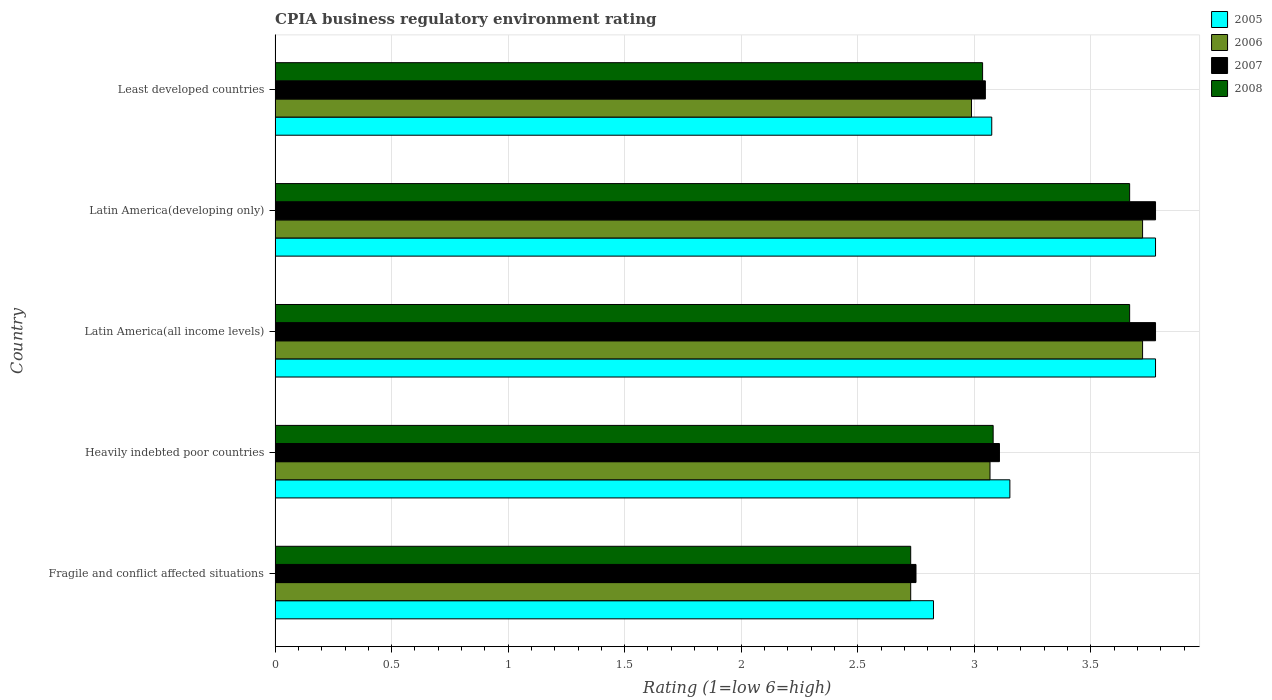How many different coloured bars are there?
Make the answer very short. 4. How many groups of bars are there?
Provide a succinct answer. 5. Are the number of bars per tick equal to the number of legend labels?
Give a very brief answer. Yes. Are the number of bars on each tick of the Y-axis equal?
Your answer should be compact. Yes. What is the label of the 4th group of bars from the top?
Offer a terse response. Heavily indebted poor countries. What is the CPIA rating in 2008 in Latin America(all income levels)?
Your answer should be compact. 3.67. Across all countries, what is the maximum CPIA rating in 2007?
Make the answer very short. 3.78. Across all countries, what is the minimum CPIA rating in 2005?
Your answer should be very brief. 2.83. In which country was the CPIA rating in 2008 maximum?
Your answer should be compact. Latin America(all income levels). In which country was the CPIA rating in 2007 minimum?
Your answer should be very brief. Fragile and conflict affected situations. What is the total CPIA rating in 2008 in the graph?
Make the answer very short. 16.18. What is the difference between the CPIA rating in 2006 in Fragile and conflict affected situations and that in Heavily indebted poor countries?
Keep it short and to the point. -0.34. What is the difference between the CPIA rating in 2008 in Heavily indebted poor countries and the CPIA rating in 2007 in Fragile and conflict affected situations?
Ensure brevity in your answer.  0.33. What is the average CPIA rating in 2008 per country?
Ensure brevity in your answer.  3.24. What is the difference between the CPIA rating in 2008 and CPIA rating in 2006 in Latin America(all income levels)?
Make the answer very short. -0.06. In how many countries, is the CPIA rating in 2006 greater than 0.7 ?
Provide a succinct answer. 5. What is the ratio of the CPIA rating in 2008 in Heavily indebted poor countries to that in Latin America(all income levels)?
Ensure brevity in your answer.  0.84. Is the CPIA rating in 2006 in Fragile and conflict affected situations less than that in Heavily indebted poor countries?
Give a very brief answer. Yes. Is the difference between the CPIA rating in 2008 in Fragile and conflict affected situations and Latin America(all income levels) greater than the difference between the CPIA rating in 2006 in Fragile and conflict affected situations and Latin America(all income levels)?
Provide a succinct answer. Yes. What is the difference between the highest and the second highest CPIA rating in 2006?
Your answer should be compact. 0. What is the difference between the highest and the lowest CPIA rating in 2006?
Your response must be concise. 0.99. Is it the case that in every country, the sum of the CPIA rating in 2007 and CPIA rating in 2005 is greater than the sum of CPIA rating in 2006 and CPIA rating in 2008?
Keep it short and to the point. No. What does the 2nd bar from the bottom in Fragile and conflict affected situations represents?
Provide a succinct answer. 2006. Is it the case that in every country, the sum of the CPIA rating in 2006 and CPIA rating in 2007 is greater than the CPIA rating in 2008?
Offer a terse response. Yes. How many countries are there in the graph?
Your answer should be very brief. 5. What is the difference between two consecutive major ticks on the X-axis?
Your answer should be compact. 0.5. Are the values on the major ticks of X-axis written in scientific E-notation?
Offer a terse response. No. Does the graph contain any zero values?
Offer a terse response. No. Does the graph contain grids?
Offer a very short reply. Yes. Where does the legend appear in the graph?
Give a very brief answer. Top right. How many legend labels are there?
Your answer should be very brief. 4. What is the title of the graph?
Your response must be concise. CPIA business regulatory environment rating. What is the label or title of the X-axis?
Give a very brief answer. Rating (1=low 6=high). What is the label or title of the Y-axis?
Provide a short and direct response. Country. What is the Rating (1=low 6=high) of 2005 in Fragile and conflict affected situations?
Give a very brief answer. 2.83. What is the Rating (1=low 6=high) in 2006 in Fragile and conflict affected situations?
Offer a very short reply. 2.73. What is the Rating (1=low 6=high) of 2007 in Fragile and conflict affected situations?
Provide a short and direct response. 2.75. What is the Rating (1=low 6=high) of 2008 in Fragile and conflict affected situations?
Keep it short and to the point. 2.73. What is the Rating (1=low 6=high) in 2005 in Heavily indebted poor countries?
Your answer should be very brief. 3.15. What is the Rating (1=low 6=high) in 2006 in Heavily indebted poor countries?
Your answer should be very brief. 3.07. What is the Rating (1=low 6=high) of 2007 in Heavily indebted poor countries?
Provide a succinct answer. 3.11. What is the Rating (1=low 6=high) in 2008 in Heavily indebted poor countries?
Ensure brevity in your answer.  3.08. What is the Rating (1=low 6=high) of 2005 in Latin America(all income levels)?
Provide a succinct answer. 3.78. What is the Rating (1=low 6=high) in 2006 in Latin America(all income levels)?
Ensure brevity in your answer.  3.72. What is the Rating (1=low 6=high) of 2007 in Latin America(all income levels)?
Ensure brevity in your answer.  3.78. What is the Rating (1=low 6=high) of 2008 in Latin America(all income levels)?
Your response must be concise. 3.67. What is the Rating (1=low 6=high) of 2005 in Latin America(developing only)?
Make the answer very short. 3.78. What is the Rating (1=low 6=high) in 2006 in Latin America(developing only)?
Provide a succinct answer. 3.72. What is the Rating (1=low 6=high) of 2007 in Latin America(developing only)?
Offer a very short reply. 3.78. What is the Rating (1=low 6=high) in 2008 in Latin America(developing only)?
Keep it short and to the point. 3.67. What is the Rating (1=low 6=high) in 2005 in Least developed countries?
Your response must be concise. 3.08. What is the Rating (1=low 6=high) in 2006 in Least developed countries?
Your response must be concise. 2.99. What is the Rating (1=low 6=high) in 2007 in Least developed countries?
Offer a very short reply. 3.05. What is the Rating (1=low 6=high) of 2008 in Least developed countries?
Ensure brevity in your answer.  3.04. Across all countries, what is the maximum Rating (1=low 6=high) of 2005?
Your answer should be compact. 3.78. Across all countries, what is the maximum Rating (1=low 6=high) of 2006?
Ensure brevity in your answer.  3.72. Across all countries, what is the maximum Rating (1=low 6=high) of 2007?
Give a very brief answer. 3.78. Across all countries, what is the maximum Rating (1=low 6=high) of 2008?
Give a very brief answer. 3.67. Across all countries, what is the minimum Rating (1=low 6=high) of 2005?
Your response must be concise. 2.83. Across all countries, what is the minimum Rating (1=low 6=high) in 2006?
Your response must be concise. 2.73. Across all countries, what is the minimum Rating (1=low 6=high) in 2007?
Offer a very short reply. 2.75. Across all countries, what is the minimum Rating (1=low 6=high) in 2008?
Keep it short and to the point. 2.73. What is the total Rating (1=low 6=high) of 2005 in the graph?
Give a very brief answer. 16.61. What is the total Rating (1=low 6=high) of 2006 in the graph?
Provide a short and direct response. 16.23. What is the total Rating (1=low 6=high) in 2007 in the graph?
Keep it short and to the point. 16.46. What is the total Rating (1=low 6=high) of 2008 in the graph?
Keep it short and to the point. 16.18. What is the difference between the Rating (1=low 6=high) in 2005 in Fragile and conflict affected situations and that in Heavily indebted poor countries?
Make the answer very short. -0.33. What is the difference between the Rating (1=low 6=high) of 2006 in Fragile and conflict affected situations and that in Heavily indebted poor countries?
Offer a terse response. -0.34. What is the difference between the Rating (1=low 6=high) in 2007 in Fragile and conflict affected situations and that in Heavily indebted poor countries?
Ensure brevity in your answer.  -0.36. What is the difference between the Rating (1=low 6=high) in 2008 in Fragile and conflict affected situations and that in Heavily indebted poor countries?
Offer a terse response. -0.35. What is the difference between the Rating (1=low 6=high) of 2005 in Fragile and conflict affected situations and that in Latin America(all income levels)?
Provide a succinct answer. -0.95. What is the difference between the Rating (1=low 6=high) of 2006 in Fragile and conflict affected situations and that in Latin America(all income levels)?
Offer a terse response. -0.99. What is the difference between the Rating (1=low 6=high) of 2007 in Fragile and conflict affected situations and that in Latin America(all income levels)?
Make the answer very short. -1.03. What is the difference between the Rating (1=low 6=high) in 2008 in Fragile and conflict affected situations and that in Latin America(all income levels)?
Make the answer very short. -0.94. What is the difference between the Rating (1=low 6=high) in 2005 in Fragile and conflict affected situations and that in Latin America(developing only)?
Your answer should be very brief. -0.95. What is the difference between the Rating (1=low 6=high) in 2006 in Fragile and conflict affected situations and that in Latin America(developing only)?
Provide a short and direct response. -0.99. What is the difference between the Rating (1=low 6=high) in 2007 in Fragile and conflict affected situations and that in Latin America(developing only)?
Keep it short and to the point. -1.03. What is the difference between the Rating (1=low 6=high) in 2008 in Fragile and conflict affected situations and that in Latin America(developing only)?
Offer a very short reply. -0.94. What is the difference between the Rating (1=low 6=high) in 2006 in Fragile and conflict affected situations and that in Least developed countries?
Offer a very short reply. -0.26. What is the difference between the Rating (1=low 6=high) in 2007 in Fragile and conflict affected situations and that in Least developed countries?
Your response must be concise. -0.3. What is the difference between the Rating (1=low 6=high) of 2008 in Fragile and conflict affected situations and that in Least developed countries?
Ensure brevity in your answer.  -0.31. What is the difference between the Rating (1=low 6=high) in 2005 in Heavily indebted poor countries and that in Latin America(all income levels)?
Provide a short and direct response. -0.62. What is the difference between the Rating (1=low 6=high) of 2006 in Heavily indebted poor countries and that in Latin America(all income levels)?
Your answer should be compact. -0.65. What is the difference between the Rating (1=low 6=high) of 2007 in Heavily indebted poor countries and that in Latin America(all income levels)?
Your response must be concise. -0.67. What is the difference between the Rating (1=low 6=high) of 2008 in Heavily indebted poor countries and that in Latin America(all income levels)?
Make the answer very short. -0.59. What is the difference between the Rating (1=low 6=high) in 2005 in Heavily indebted poor countries and that in Latin America(developing only)?
Your answer should be compact. -0.62. What is the difference between the Rating (1=low 6=high) in 2006 in Heavily indebted poor countries and that in Latin America(developing only)?
Keep it short and to the point. -0.65. What is the difference between the Rating (1=low 6=high) in 2007 in Heavily indebted poor countries and that in Latin America(developing only)?
Keep it short and to the point. -0.67. What is the difference between the Rating (1=low 6=high) of 2008 in Heavily indebted poor countries and that in Latin America(developing only)?
Your answer should be very brief. -0.59. What is the difference between the Rating (1=low 6=high) of 2005 in Heavily indebted poor countries and that in Least developed countries?
Offer a terse response. 0.08. What is the difference between the Rating (1=low 6=high) of 2006 in Heavily indebted poor countries and that in Least developed countries?
Your answer should be compact. 0.08. What is the difference between the Rating (1=low 6=high) in 2007 in Heavily indebted poor countries and that in Least developed countries?
Ensure brevity in your answer.  0.06. What is the difference between the Rating (1=low 6=high) in 2008 in Heavily indebted poor countries and that in Least developed countries?
Your response must be concise. 0.05. What is the difference between the Rating (1=low 6=high) of 2005 in Latin America(all income levels) and that in Latin America(developing only)?
Keep it short and to the point. 0. What is the difference between the Rating (1=low 6=high) in 2005 in Latin America(all income levels) and that in Least developed countries?
Your answer should be compact. 0.7. What is the difference between the Rating (1=low 6=high) of 2006 in Latin America(all income levels) and that in Least developed countries?
Your response must be concise. 0.73. What is the difference between the Rating (1=low 6=high) of 2007 in Latin America(all income levels) and that in Least developed countries?
Your answer should be very brief. 0.73. What is the difference between the Rating (1=low 6=high) of 2008 in Latin America(all income levels) and that in Least developed countries?
Keep it short and to the point. 0.63. What is the difference between the Rating (1=low 6=high) in 2005 in Latin America(developing only) and that in Least developed countries?
Your answer should be very brief. 0.7. What is the difference between the Rating (1=low 6=high) in 2006 in Latin America(developing only) and that in Least developed countries?
Keep it short and to the point. 0.73. What is the difference between the Rating (1=low 6=high) of 2007 in Latin America(developing only) and that in Least developed countries?
Provide a short and direct response. 0.73. What is the difference between the Rating (1=low 6=high) of 2008 in Latin America(developing only) and that in Least developed countries?
Provide a succinct answer. 0.63. What is the difference between the Rating (1=low 6=high) in 2005 in Fragile and conflict affected situations and the Rating (1=low 6=high) in 2006 in Heavily indebted poor countries?
Your answer should be very brief. -0.24. What is the difference between the Rating (1=low 6=high) in 2005 in Fragile and conflict affected situations and the Rating (1=low 6=high) in 2007 in Heavily indebted poor countries?
Provide a succinct answer. -0.28. What is the difference between the Rating (1=low 6=high) of 2005 in Fragile and conflict affected situations and the Rating (1=low 6=high) of 2008 in Heavily indebted poor countries?
Make the answer very short. -0.26. What is the difference between the Rating (1=low 6=high) of 2006 in Fragile and conflict affected situations and the Rating (1=low 6=high) of 2007 in Heavily indebted poor countries?
Your answer should be very brief. -0.38. What is the difference between the Rating (1=low 6=high) in 2006 in Fragile and conflict affected situations and the Rating (1=low 6=high) in 2008 in Heavily indebted poor countries?
Keep it short and to the point. -0.35. What is the difference between the Rating (1=low 6=high) of 2007 in Fragile and conflict affected situations and the Rating (1=low 6=high) of 2008 in Heavily indebted poor countries?
Your answer should be very brief. -0.33. What is the difference between the Rating (1=low 6=high) of 2005 in Fragile and conflict affected situations and the Rating (1=low 6=high) of 2006 in Latin America(all income levels)?
Your answer should be very brief. -0.9. What is the difference between the Rating (1=low 6=high) in 2005 in Fragile and conflict affected situations and the Rating (1=low 6=high) in 2007 in Latin America(all income levels)?
Provide a short and direct response. -0.95. What is the difference between the Rating (1=low 6=high) in 2005 in Fragile and conflict affected situations and the Rating (1=low 6=high) in 2008 in Latin America(all income levels)?
Offer a very short reply. -0.84. What is the difference between the Rating (1=low 6=high) of 2006 in Fragile and conflict affected situations and the Rating (1=low 6=high) of 2007 in Latin America(all income levels)?
Provide a succinct answer. -1.05. What is the difference between the Rating (1=low 6=high) in 2006 in Fragile and conflict affected situations and the Rating (1=low 6=high) in 2008 in Latin America(all income levels)?
Offer a very short reply. -0.94. What is the difference between the Rating (1=low 6=high) of 2007 in Fragile and conflict affected situations and the Rating (1=low 6=high) of 2008 in Latin America(all income levels)?
Give a very brief answer. -0.92. What is the difference between the Rating (1=low 6=high) of 2005 in Fragile and conflict affected situations and the Rating (1=low 6=high) of 2006 in Latin America(developing only)?
Offer a very short reply. -0.9. What is the difference between the Rating (1=low 6=high) of 2005 in Fragile and conflict affected situations and the Rating (1=low 6=high) of 2007 in Latin America(developing only)?
Provide a short and direct response. -0.95. What is the difference between the Rating (1=low 6=high) in 2005 in Fragile and conflict affected situations and the Rating (1=low 6=high) in 2008 in Latin America(developing only)?
Offer a terse response. -0.84. What is the difference between the Rating (1=low 6=high) in 2006 in Fragile and conflict affected situations and the Rating (1=low 6=high) in 2007 in Latin America(developing only)?
Provide a short and direct response. -1.05. What is the difference between the Rating (1=low 6=high) of 2006 in Fragile and conflict affected situations and the Rating (1=low 6=high) of 2008 in Latin America(developing only)?
Your response must be concise. -0.94. What is the difference between the Rating (1=low 6=high) of 2007 in Fragile and conflict affected situations and the Rating (1=low 6=high) of 2008 in Latin America(developing only)?
Make the answer very short. -0.92. What is the difference between the Rating (1=low 6=high) of 2005 in Fragile and conflict affected situations and the Rating (1=low 6=high) of 2006 in Least developed countries?
Give a very brief answer. -0.16. What is the difference between the Rating (1=low 6=high) in 2005 in Fragile and conflict affected situations and the Rating (1=low 6=high) in 2007 in Least developed countries?
Give a very brief answer. -0.22. What is the difference between the Rating (1=low 6=high) of 2005 in Fragile and conflict affected situations and the Rating (1=low 6=high) of 2008 in Least developed countries?
Keep it short and to the point. -0.21. What is the difference between the Rating (1=low 6=high) in 2006 in Fragile and conflict affected situations and the Rating (1=low 6=high) in 2007 in Least developed countries?
Your response must be concise. -0.32. What is the difference between the Rating (1=low 6=high) in 2006 in Fragile and conflict affected situations and the Rating (1=low 6=high) in 2008 in Least developed countries?
Provide a succinct answer. -0.31. What is the difference between the Rating (1=low 6=high) in 2007 in Fragile and conflict affected situations and the Rating (1=low 6=high) in 2008 in Least developed countries?
Provide a short and direct response. -0.29. What is the difference between the Rating (1=low 6=high) in 2005 in Heavily indebted poor countries and the Rating (1=low 6=high) in 2006 in Latin America(all income levels)?
Offer a very short reply. -0.57. What is the difference between the Rating (1=low 6=high) in 2005 in Heavily indebted poor countries and the Rating (1=low 6=high) in 2007 in Latin America(all income levels)?
Keep it short and to the point. -0.62. What is the difference between the Rating (1=low 6=high) of 2005 in Heavily indebted poor countries and the Rating (1=low 6=high) of 2008 in Latin America(all income levels)?
Keep it short and to the point. -0.51. What is the difference between the Rating (1=low 6=high) of 2006 in Heavily indebted poor countries and the Rating (1=low 6=high) of 2007 in Latin America(all income levels)?
Keep it short and to the point. -0.71. What is the difference between the Rating (1=low 6=high) of 2006 in Heavily indebted poor countries and the Rating (1=low 6=high) of 2008 in Latin America(all income levels)?
Keep it short and to the point. -0.6. What is the difference between the Rating (1=low 6=high) of 2007 in Heavily indebted poor countries and the Rating (1=low 6=high) of 2008 in Latin America(all income levels)?
Your response must be concise. -0.56. What is the difference between the Rating (1=low 6=high) of 2005 in Heavily indebted poor countries and the Rating (1=low 6=high) of 2006 in Latin America(developing only)?
Make the answer very short. -0.57. What is the difference between the Rating (1=low 6=high) in 2005 in Heavily indebted poor countries and the Rating (1=low 6=high) in 2007 in Latin America(developing only)?
Give a very brief answer. -0.62. What is the difference between the Rating (1=low 6=high) of 2005 in Heavily indebted poor countries and the Rating (1=low 6=high) of 2008 in Latin America(developing only)?
Keep it short and to the point. -0.51. What is the difference between the Rating (1=low 6=high) in 2006 in Heavily indebted poor countries and the Rating (1=low 6=high) in 2007 in Latin America(developing only)?
Make the answer very short. -0.71. What is the difference between the Rating (1=low 6=high) of 2006 in Heavily indebted poor countries and the Rating (1=low 6=high) of 2008 in Latin America(developing only)?
Keep it short and to the point. -0.6. What is the difference between the Rating (1=low 6=high) in 2007 in Heavily indebted poor countries and the Rating (1=low 6=high) in 2008 in Latin America(developing only)?
Your answer should be very brief. -0.56. What is the difference between the Rating (1=low 6=high) of 2005 in Heavily indebted poor countries and the Rating (1=low 6=high) of 2006 in Least developed countries?
Provide a short and direct response. 0.16. What is the difference between the Rating (1=low 6=high) in 2005 in Heavily indebted poor countries and the Rating (1=low 6=high) in 2007 in Least developed countries?
Your answer should be compact. 0.11. What is the difference between the Rating (1=low 6=high) in 2005 in Heavily indebted poor countries and the Rating (1=low 6=high) in 2008 in Least developed countries?
Offer a very short reply. 0.12. What is the difference between the Rating (1=low 6=high) in 2006 in Heavily indebted poor countries and the Rating (1=low 6=high) in 2007 in Least developed countries?
Keep it short and to the point. 0.02. What is the difference between the Rating (1=low 6=high) in 2006 in Heavily indebted poor countries and the Rating (1=low 6=high) in 2008 in Least developed countries?
Provide a succinct answer. 0.03. What is the difference between the Rating (1=low 6=high) of 2007 in Heavily indebted poor countries and the Rating (1=low 6=high) of 2008 in Least developed countries?
Ensure brevity in your answer.  0.07. What is the difference between the Rating (1=low 6=high) of 2005 in Latin America(all income levels) and the Rating (1=low 6=high) of 2006 in Latin America(developing only)?
Offer a very short reply. 0.06. What is the difference between the Rating (1=low 6=high) in 2005 in Latin America(all income levels) and the Rating (1=low 6=high) in 2008 in Latin America(developing only)?
Provide a short and direct response. 0.11. What is the difference between the Rating (1=low 6=high) of 2006 in Latin America(all income levels) and the Rating (1=low 6=high) of 2007 in Latin America(developing only)?
Provide a short and direct response. -0.06. What is the difference between the Rating (1=low 6=high) in 2006 in Latin America(all income levels) and the Rating (1=low 6=high) in 2008 in Latin America(developing only)?
Offer a terse response. 0.06. What is the difference between the Rating (1=low 6=high) of 2007 in Latin America(all income levels) and the Rating (1=low 6=high) of 2008 in Latin America(developing only)?
Offer a terse response. 0.11. What is the difference between the Rating (1=low 6=high) in 2005 in Latin America(all income levels) and the Rating (1=low 6=high) in 2006 in Least developed countries?
Provide a short and direct response. 0.79. What is the difference between the Rating (1=low 6=high) of 2005 in Latin America(all income levels) and the Rating (1=low 6=high) of 2007 in Least developed countries?
Provide a succinct answer. 0.73. What is the difference between the Rating (1=low 6=high) of 2005 in Latin America(all income levels) and the Rating (1=low 6=high) of 2008 in Least developed countries?
Your answer should be compact. 0.74. What is the difference between the Rating (1=low 6=high) of 2006 in Latin America(all income levels) and the Rating (1=low 6=high) of 2007 in Least developed countries?
Your response must be concise. 0.67. What is the difference between the Rating (1=low 6=high) in 2006 in Latin America(all income levels) and the Rating (1=low 6=high) in 2008 in Least developed countries?
Ensure brevity in your answer.  0.69. What is the difference between the Rating (1=low 6=high) of 2007 in Latin America(all income levels) and the Rating (1=low 6=high) of 2008 in Least developed countries?
Give a very brief answer. 0.74. What is the difference between the Rating (1=low 6=high) of 2005 in Latin America(developing only) and the Rating (1=low 6=high) of 2006 in Least developed countries?
Keep it short and to the point. 0.79. What is the difference between the Rating (1=low 6=high) of 2005 in Latin America(developing only) and the Rating (1=low 6=high) of 2007 in Least developed countries?
Your answer should be very brief. 0.73. What is the difference between the Rating (1=low 6=high) of 2005 in Latin America(developing only) and the Rating (1=low 6=high) of 2008 in Least developed countries?
Offer a very short reply. 0.74. What is the difference between the Rating (1=low 6=high) in 2006 in Latin America(developing only) and the Rating (1=low 6=high) in 2007 in Least developed countries?
Offer a very short reply. 0.67. What is the difference between the Rating (1=low 6=high) of 2006 in Latin America(developing only) and the Rating (1=low 6=high) of 2008 in Least developed countries?
Ensure brevity in your answer.  0.69. What is the difference between the Rating (1=low 6=high) in 2007 in Latin America(developing only) and the Rating (1=low 6=high) in 2008 in Least developed countries?
Offer a terse response. 0.74. What is the average Rating (1=low 6=high) of 2005 per country?
Give a very brief answer. 3.32. What is the average Rating (1=low 6=high) of 2006 per country?
Offer a very short reply. 3.25. What is the average Rating (1=low 6=high) of 2007 per country?
Give a very brief answer. 3.29. What is the average Rating (1=low 6=high) in 2008 per country?
Provide a short and direct response. 3.24. What is the difference between the Rating (1=low 6=high) in 2005 and Rating (1=low 6=high) in 2006 in Fragile and conflict affected situations?
Provide a short and direct response. 0.1. What is the difference between the Rating (1=low 6=high) of 2005 and Rating (1=low 6=high) of 2007 in Fragile and conflict affected situations?
Give a very brief answer. 0.07. What is the difference between the Rating (1=low 6=high) of 2005 and Rating (1=low 6=high) of 2008 in Fragile and conflict affected situations?
Your answer should be very brief. 0.1. What is the difference between the Rating (1=low 6=high) of 2006 and Rating (1=low 6=high) of 2007 in Fragile and conflict affected situations?
Keep it short and to the point. -0.02. What is the difference between the Rating (1=low 6=high) in 2007 and Rating (1=low 6=high) in 2008 in Fragile and conflict affected situations?
Offer a very short reply. 0.02. What is the difference between the Rating (1=low 6=high) of 2005 and Rating (1=low 6=high) of 2006 in Heavily indebted poor countries?
Make the answer very short. 0.09. What is the difference between the Rating (1=low 6=high) in 2005 and Rating (1=low 6=high) in 2007 in Heavily indebted poor countries?
Offer a very short reply. 0.04. What is the difference between the Rating (1=low 6=high) in 2005 and Rating (1=low 6=high) in 2008 in Heavily indebted poor countries?
Make the answer very short. 0.07. What is the difference between the Rating (1=low 6=high) of 2006 and Rating (1=low 6=high) of 2007 in Heavily indebted poor countries?
Your response must be concise. -0.04. What is the difference between the Rating (1=low 6=high) of 2006 and Rating (1=low 6=high) of 2008 in Heavily indebted poor countries?
Provide a short and direct response. -0.01. What is the difference between the Rating (1=low 6=high) of 2007 and Rating (1=low 6=high) of 2008 in Heavily indebted poor countries?
Keep it short and to the point. 0.03. What is the difference between the Rating (1=low 6=high) of 2005 and Rating (1=low 6=high) of 2006 in Latin America(all income levels)?
Give a very brief answer. 0.06. What is the difference between the Rating (1=low 6=high) in 2005 and Rating (1=low 6=high) in 2007 in Latin America(all income levels)?
Provide a short and direct response. 0. What is the difference between the Rating (1=low 6=high) in 2005 and Rating (1=low 6=high) in 2008 in Latin America(all income levels)?
Make the answer very short. 0.11. What is the difference between the Rating (1=low 6=high) of 2006 and Rating (1=low 6=high) of 2007 in Latin America(all income levels)?
Offer a terse response. -0.06. What is the difference between the Rating (1=low 6=high) of 2006 and Rating (1=low 6=high) of 2008 in Latin America(all income levels)?
Your answer should be very brief. 0.06. What is the difference between the Rating (1=low 6=high) of 2007 and Rating (1=low 6=high) of 2008 in Latin America(all income levels)?
Ensure brevity in your answer.  0.11. What is the difference between the Rating (1=low 6=high) in 2005 and Rating (1=low 6=high) in 2006 in Latin America(developing only)?
Make the answer very short. 0.06. What is the difference between the Rating (1=low 6=high) in 2005 and Rating (1=low 6=high) in 2008 in Latin America(developing only)?
Ensure brevity in your answer.  0.11. What is the difference between the Rating (1=low 6=high) of 2006 and Rating (1=low 6=high) of 2007 in Latin America(developing only)?
Ensure brevity in your answer.  -0.06. What is the difference between the Rating (1=low 6=high) in 2006 and Rating (1=low 6=high) in 2008 in Latin America(developing only)?
Your answer should be compact. 0.06. What is the difference between the Rating (1=low 6=high) of 2007 and Rating (1=low 6=high) of 2008 in Latin America(developing only)?
Make the answer very short. 0.11. What is the difference between the Rating (1=low 6=high) of 2005 and Rating (1=low 6=high) of 2006 in Least developed countries?
Offer a very short reply. 0.09. What is the difference between the Rating (1=low 6=high) in 2005 and Rating (1=low 6=high) in 2007 in Least developed countries?
Offer a terse response. 0.03. What is the difference between the Rating (1=low 6=high) in 2005 and Rating (1=low 6=high) in 2008 in Least developed countries?
Ensure brevity in your answer.  0.04. What is the difference between the Rating (1=low 6=high) of 2006 and Rating (1=low 6=high) of 2007 in Least developed countries?
Ensure brevity in your answer.  -0.06. What is the difference between the Rating (1=low 6=high) of 2006 and Rating (1=low 6=high) of 2008 in Least developed countries?
Your answer should be very brief. -0.05. What is the difference between the Rating (1=low 6=high) in 2007 and Rating (1=low 6=high) in 2008 in Least developed countries?
Give a very brief answer. 0.01. What is the ratio of the Rating (1=low 6=high) of 2005 in Fragile and conflict affected situations to that in Heavily indebted poor countries?
Give a very brief answer. 0.9. What is the ratio of the Rating (1=low 6=high) of 2006 in Fragile and conflict affected situations to that in Heavily indebted poor countries?
Offer a very short reply. 0.89. What is the ratio of the Rating (1=low 6=high) of 2007 in Fragile and conflict affected situations to that in Heavily indebted poor countries?
Provide a short and direct response. 0.88. What is the ratio of the Rating (1=low 6=high) in 2008 in Fragile and conflict affected situations to that in Heavily indebted poor countries?
Provide a succinct answer. 0.89. What is the ratio of the Rating (1=low 6=high) of 2005 in Fragile and conflict affected situations to that in Latin America(all income levels)?
Your answer should be compact. 0.75. What is the ratio of the Rating (1=low 6=high) in 2006 in Fragile and conflict affected situations to that in Latin America(all income levels)?
Your answer should be very brief. 0.73. What is the ratio of the Rating (1=low 6=high) in 2007 in Fragile and conflict affected situations to that in Latin America(all income levels)?
Offer a very short reply. 0.73. What is the ratio of the Rating (1=low 6=high) of 2008 in Fragile and conflict affected situations to that in Latin America(all income levels)?
Your answer should be very brief. 0.74. What is the ratio of the Rating (1=low 6=high) of 2005 in Fragile and conflict affected situations to that in Latin America(developing only)?
Provide a short and direct response. 0.75. What is the ratio of the Rating (1=low 6=high) in 2006 in Fragile and conflict affected situations to that in Latin America(developing only)?
Your response must be concise. 0.73. What is the ratio of the Rating (1=low 6=high) of 2007 in Fragile and conflict affected situations to that in Latin America(developing only)?
Give a very brief answer. 0.73. What is the ratio of the Rating (1=low 6=high) of 2008 in Fragile and conflict affected situations to that in Latin America(developing only)?
Offer a very short reply. 0.74. What is the ratio of the Rating (1=low 6=high) in 2005 in Fragile and conflict affected situations to that in Least developed countries?
Keep it short and to the point. 0.92. What is the ratio of the Rating (1=low 6=high) in 2006 in Fragile and conflict affected situations to that in Least developed countries?
Give a very brief answer. 0.91. What is the ratio of the Rating (1=low 6=high) of 2007 in Fragile and conflict affected situations to that in Least developed countries?
Keep it short and to the point. 0.9. What is the ratio of the Rating (1=low 6=high) in 2008 in Fragile and conflict affected situations to that in Least developed countries?
Your answer should be compact. 0.9. What is the ratio of the Rating (1=low 6=high) of 2005 in Heavily indebted poor countries to that in Latin America(all income levels)?
Provide a succinct answer. 0.83. What is the ratio of the Rating (1=low 6=high) in 2006 in Heavily indebted poor countries to that in Latin America(all income levels)?
Offer a very short reply. 0.82. What is the ratio of the Rating (1=low 6=high) of 2007 in Heavily indebted poor countries to that in Latin America(all income levels)?
Ensure brevity in your answer.  0.82. What is the ratio of the Rating (1=low 6=high) in 2008 in Heavily indebted poor countries to that in Latin America(all income levels)?
Offer a very short reply. 0.84. What is the ratio of the Rating (1=low 6=high) of 2005 in Heavily indebted poor countries to that in Latin America(developing only)?
Provide a succinct answer. 0.83. What is the ratio of the Rating (1=low 6=high) of 2006 in Heavily indebted poor countries to that in Latin America(developing only)?
Offer a very short reply. 0.82. What is the ratio of the Rating (1=low 6=high) in 2007 in Heavily indebted poor countries to that in Latin America(developing only)?
Ensure brevity in your answer.  0.82. What is the ratio of the Rating (1=low 6=high) of 2008 in Heavily indebted poor countries to that in Latin America(developing only)?
Give a very brief answer. 0.84. What is the ratio of the Rating (1=low 6=high) in 2005 in Heavily indebted poor countries to that in Least developed countries?
Keep it short and to the point. 1.03. What is the ratio of the Rating (1=low 6=high) in 2006 in Heavily indebted poor countries to that in Least developed countries?
Provide a short and direct response. 1.03. What is the ratio of the Rating (1=low 6=high) of 2007 in Heavily indebted poor countries to that in Least developed countries?
Keep it short and to the point. 1.02. What is the ratio of the Rating (1=low 6=high) of 2008 in Heavily indebted poor countries to that in Least developed countries?
Offer a terse response. 1.01. What is the ratio of the Rating (1=low 6=high) in 2005 in Latin America(all income levels) to that in Latin America(developing only)?
Keep it short and to the point. 1. What is the ratio of the Rating (1=low 6=high) in 2006 in Latin America(all income levels) to that in Latin America(developing only)?
Your response must be concise. 1. What is the ratio of the Rating (1=low 6=high) of 2008 in Latin America(all income levels) to that in Latin America(developing only)?
Keep it short and to the point. 1. What is the ratio of the Rating (1=low 6=high) in 2005 in Latin America(all income levels) to that in Least developed countries?
Offer a terse response. 1.23. What is the ratio of the Rating (1=low 6=high) in 2006 in Latin America(all income levels) to that in Least developed countries?
Your response must be concise. 1.25. What is the ratio of the Rating (1=low 6=high) of 2007 in Latin America(all income levels) to that in Least developed countries?
Offer a terse response. 1.24. What is the ratio of the Rating (1=low 6=high) of 2008 in Latin America(all income levels) to that in Least developed countries?
Make the answer very short. 1.21. What is the ratio of the Rating (1=low 6=high) in 2005 in Latin America(developing only) to that in Least developed countries?
Ensure brevity in your answer.  1.23. What is the ratio of the Rating (1=low 6=high) in 2006 in Latin America(developing only) to that in Least developed countries?
Make the answer very short. 1.25. What is the ratio of the Rating (1=low 6=high) in 2007 in Latin America(developing only) to that in Least developed countries?
Your answer should be compact. 1.24. What is the ratio of the Rating (1=low 6=high) of 2008 in Latin America(developing only) to that in Least developed countries?
Keep it short and to the point. 1.21. What is the difference between the highest and the second highest Rating (1=low 6=high) of 2006?
Offer a terse response. 0. What is the difference between the highest and the second highest Rating (1=low 6=high) in 2007?
Ensure brevity in your answer.  0. What is the difference between the highest and the lowest Rating (1=low 6=high) of 2005?
Your response must be concise. 0.95. What is the difference between the highest and the lowest Rating (1=low 6=high) of 2006?
Your answer should be compact. 0.99. What is the difference between the highest and the lowest Rating (1=low 6=high) of 2007?
Offer a terse response. 1.03. What is the difference between the highest and the lowest Rating (1=low 6=high) in 2008?
Your answer should be very brief. 0.94. 